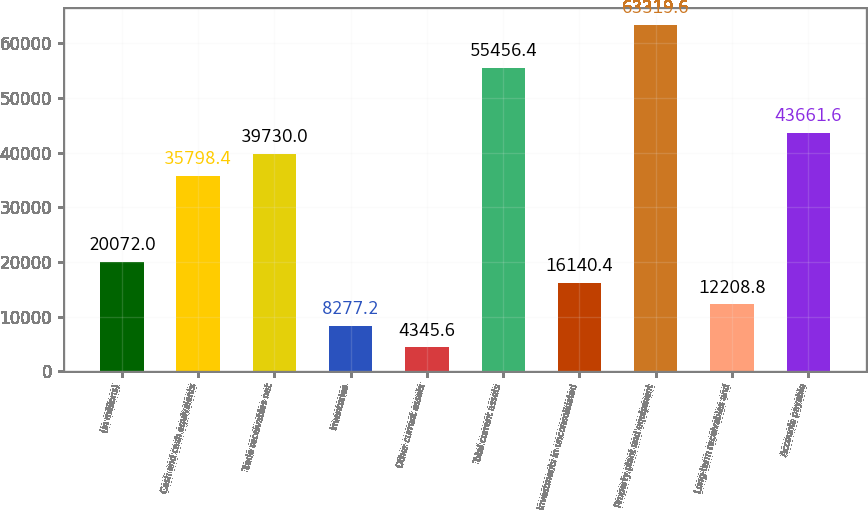Convert chart. <chart><loc_0><loc_0><loc_500><loc_500><bar_chart><fcel>(in millions)<fcel>Cash and cash equivalents<fcel>Trade receivables net<fcel>Inventories<fcel>Other current assets<fcel>Total current assets<fcel>Investments in unconsolidated<fcel>Property plant and equipment<fcel>Long-term receivables and<fcel>Accounts payable<nl><fcel>20072<fcel>35798.4<fcel>39730<fcel>8277.2<fcel>4345.6<fcel>55456.4<fcel>16140.4<fcel>63319.6<fcel>12208.8<fcel>43661.6<nl></chart> 